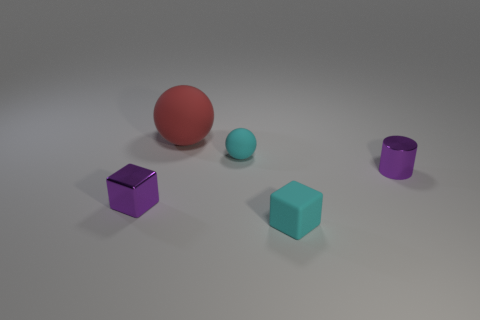What shape is the thing that is both to the left of the tiny ball and in front of the red matte object?
Your answer should be very brief. Cube. Are there any other things that are the same size as the red object?
Give a very brief answer. No. The matte object that is in front of the tiny purple object right of the purple metal cube is what color?
Give a very brief answer. Cyan. The tiny purple shiny object that is left of the tiny cube that is in front of the metallic thing that is left of the big red object is what shape?
Make the answer very short. Cube. How big is the rubber thing that is both to the right of the large red sphere and behind the small shiny cube?
Provide a short and direct response. Small. How many shiny cylinders are the same color as the tiny rubber block?
Offer a terse response. 0. What material is the sphere that is the same color as the matte cube?
Provide a succinct answer. Rubber. What is the material of the red thing?
Your answer should be compact. Rubber. Is the purple object that is on the left side of the big rubber ball made of the same material as the large red ball?
Your response must be concise. No. What is the shape of the tiny metal object that is right of the tiny purple metallic cube?
Offer a terse response. Cylinder. 